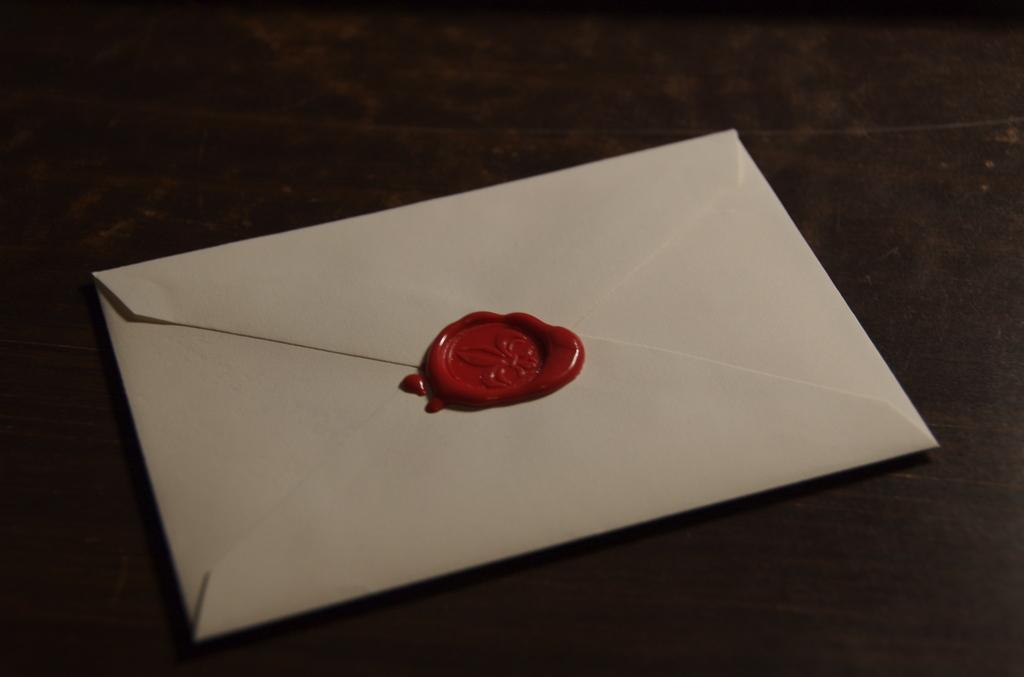What object can be seen in the image? There is a white envelope in the image. What is the appearance of the envelope? The envelope has red wax on it. Where is the envelope located? The envelope is placed on a surface. What type of act is the envelope performing in the image? The envelope is not performing any act in the image; it is simply an object placed on a surface. 